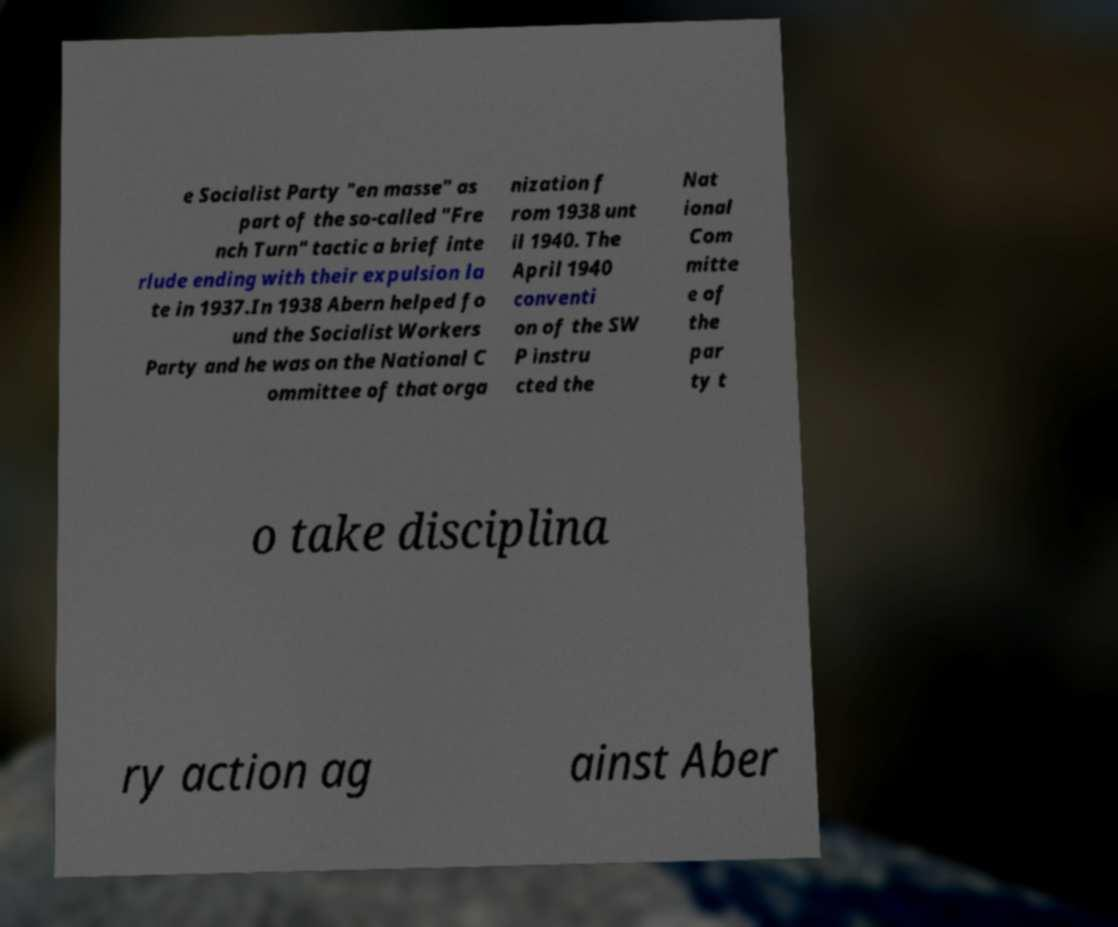I need the written content from this picture converted into text. Can you do that? e Socialist Party "en masse" as part of the so-called "Fre nch Turn" tactic a brief inte rlude ending with their expulsion la te in 1937.In 1938 Abern helped fo und the Socialist Workers Party and he was on the National C ommittee of that orga nization f rom 1938 unt il 1940. The April 1940 conventi on of the SW P instru cted the Nat ional Com mitte e of the par ty t o take disciplina ry action ag ainst Aber 